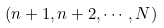Convert formula to latex. <formula><loc_0><loc_0><loc_500><loc_500>( n + 1 , n + 2 , \cdots , N )</formula> 